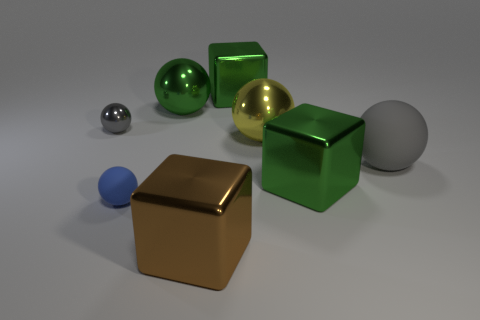How many other objects are the same color as the large matte thing?
Ensure brevity in your answer.  1. What material is the large green thing that is the same shape as the yellow thing?
Provide a succinct answer. Metal. What is the brown block made of?
Ensure brevity in your answer.  Metal. What is the green object that is both behind the gray rubber thing and on the right side of the green metallic sphere made of?
Offer a terse response. Metal. There is a tiny metallic sphere; does it have the same color as the matte ball on the right side of the yellow ball?
Make the answer very short. Yes. There is a gray object that is the same size as the yellow shiny thing; what is its material?
Keep it short and to the point. Rubber. Does the large brown object have the same material as the green block behind the large gray rubber ball?
Offer a very short reply. Yes. There is a thing that is the same color as the small metallic sphere; what material is it?
Provide a short and direct response. Rubber. How many large rubber things have the same color as the tiny metallic sphere?
Your answer should be very brief. 1. The brown metallic object is what size?
Your answer should be very brief. Large. 